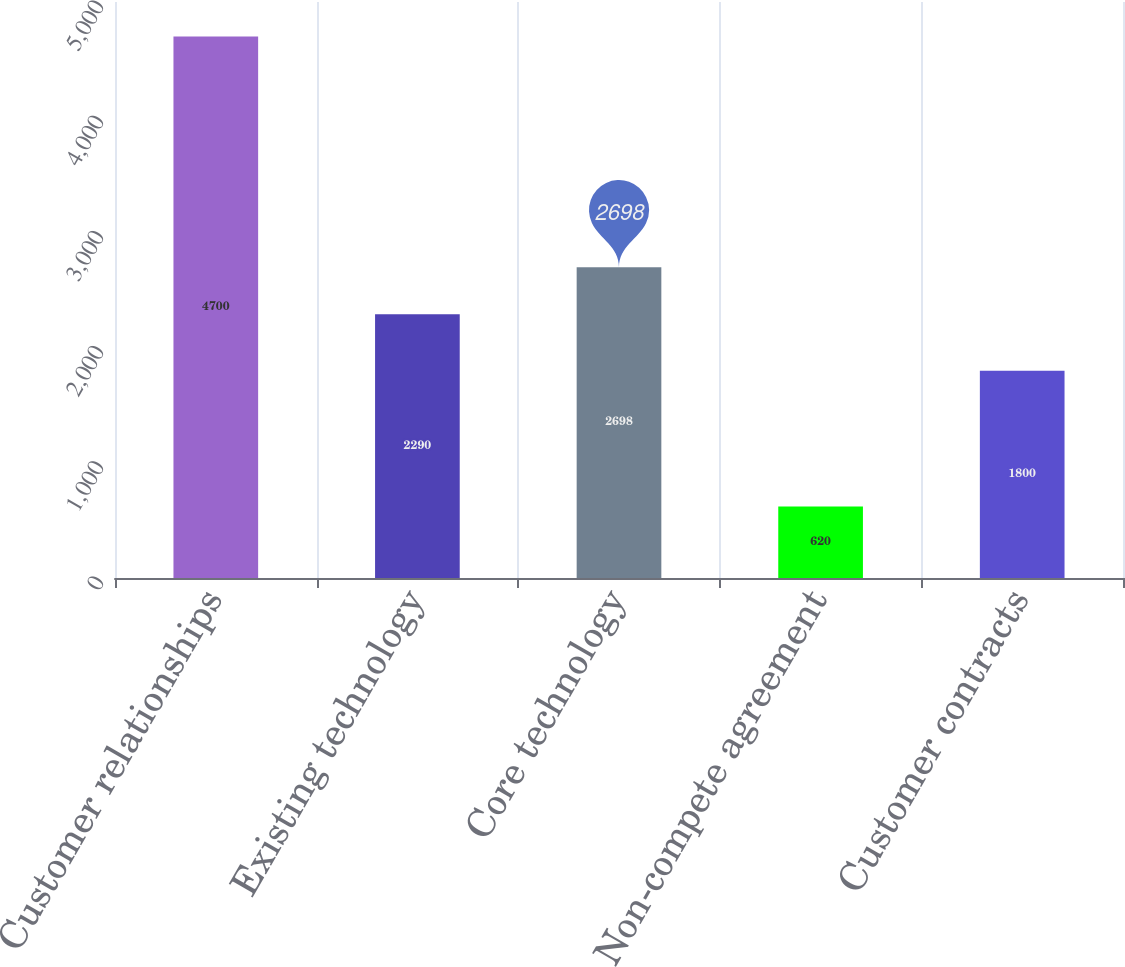<chart> <loc_0><loc_0><loc_500><loc_500><bar_chart><fcel>Customer relationships<fcel>Existing technology<fcel>Core technology<fcel>Non-compete agreement<fcel>Customer contracts<nl><fcel>4700<fcel>2290<fcel>2698<fcel>620<fcel>1800<nl></chart> 